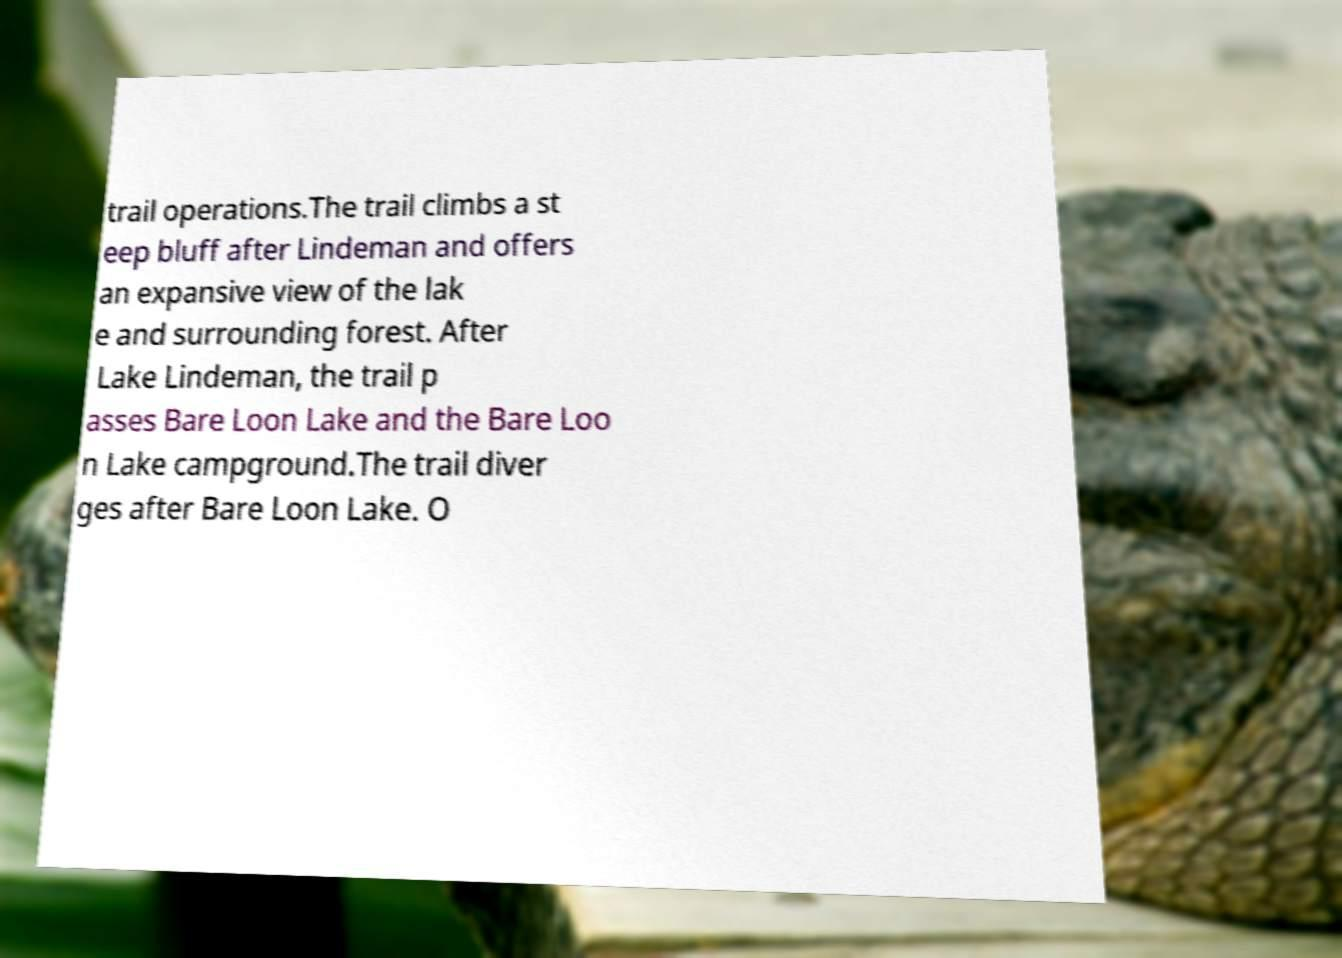Could you assist in decoding the text presented in this image and type it out clearly? trail operations.The trail climbs a st eep bluff after Lindeman and offers an expansive view of the lak e and surrounding forest. After Lake Lindeman, the trail p asses Bare Loon Lake and the Bare Loo n Lake campground.The trail diver ges after Bare Loon Lake. O 